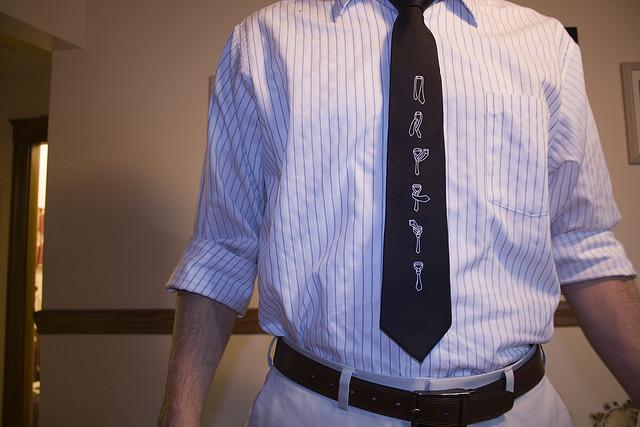The pictograms on the tie show how to do what? Please explain your reasoning. tie it. The diagrams show how to tie a simple knot in a tie. 